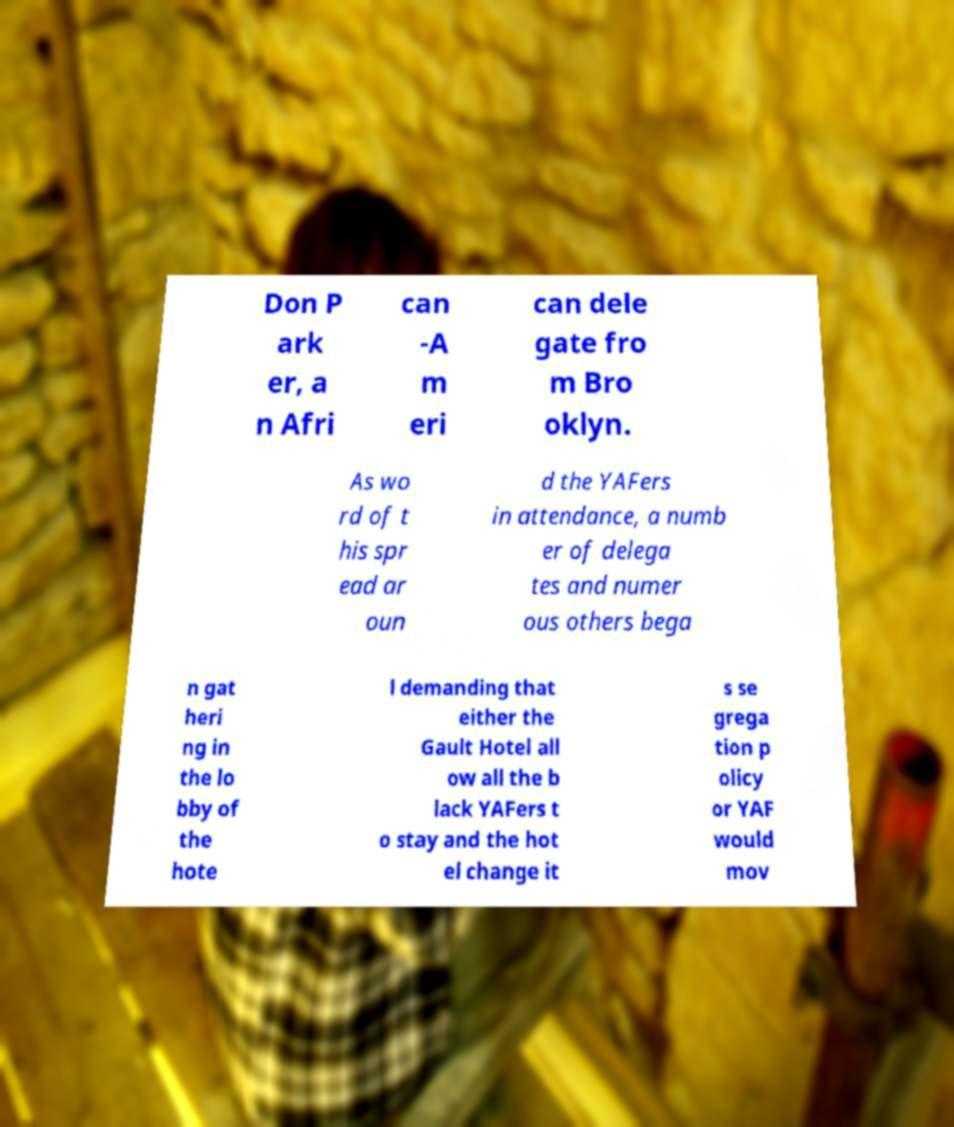I need the written content from this picture converted into text. Can you do that? Don P ark er, a n Afri can -A m eri can dele gate fro m Bro oklyn. As wo rd of t his spr ead ar oun d the YAFers in attendance, a numb er of delega tes and numer ous others bega n gat heri ng in the lo bby of the hote l demanding that either the Gault Hotel all ow all the b lack YAFers t o stay and the hot el change it s se grega tion p olicy or YAF would mov 